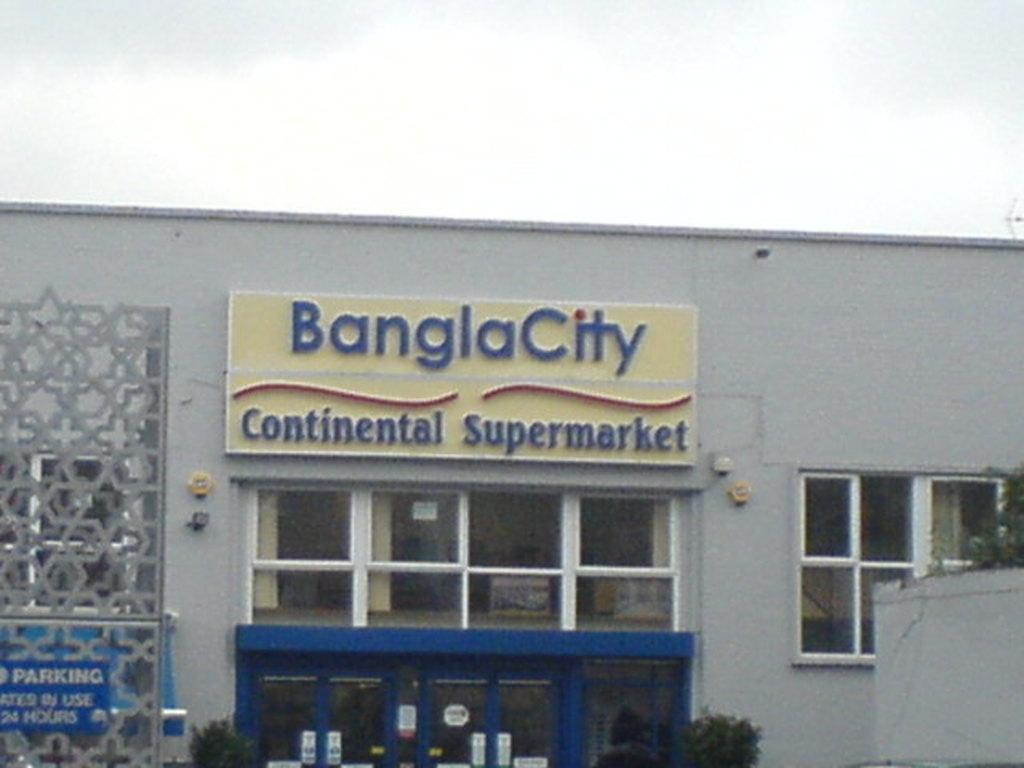What type of structure is in the image? There is a building in the image. What features can be seen on the building? The building has windows and doors. Is there any text visible in the image? Yes, there is some text visible in the image. What degree does the spade have in the image? There is no spade present in the image, so it is not possible to determine if it has a degree. 